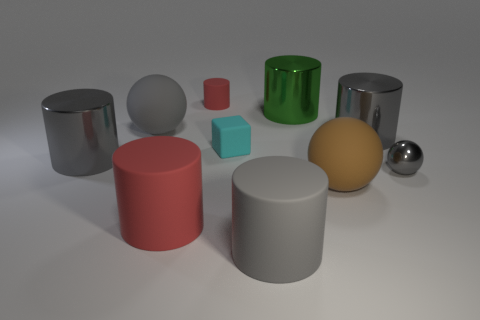The big matte object that is the same color as the tiny rubber cylinder is what shape?
Provide a short and direct response. Cylinder. What size is the other matte cylinder that is the same color as the tiny matte cylinder?
Provide a short and direct response. Large. Do the cyan thing and the brown matte object have the same shape?
Offer a very short reply. No. There is a gray rubber object that is the same shape as the big red matte thing; what is its size?
Give a very brief answer. Large. There is a rubber object that is to the right of the big gray rubber thing to the right of the tiny rubber cube; what shape is it?
Provide a short and direct response. Sphere. The green shiny thing is what size?
Keep it short and to the point. Large. There is a cyan rubber thing; what shape is it?
Provide a short and direct response. Cube. There is a brown matte object; does it have the same shape as the red rubber thing that is behind the green shiny thing?
Ensure brevity in your answer.  No. There is a gray matte thing that is in front of the large gray sphere; is its shape the same as the tiny gray thing?
Make the answer very short. No. How many large objects are to the left of the big gray rubber ball and in front of the big brown rubber ball?
Ensure brevity in your answer.  0. 